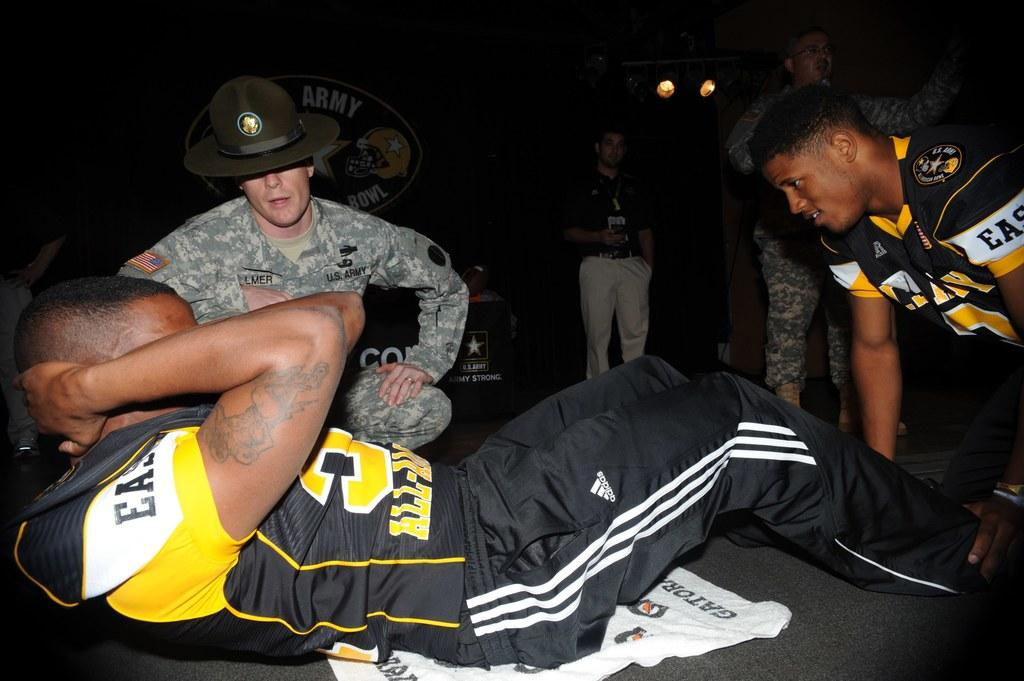Provide a one-sentence caption for the provided image. A man in a football jersey doing situps while a US Army member watches on. 